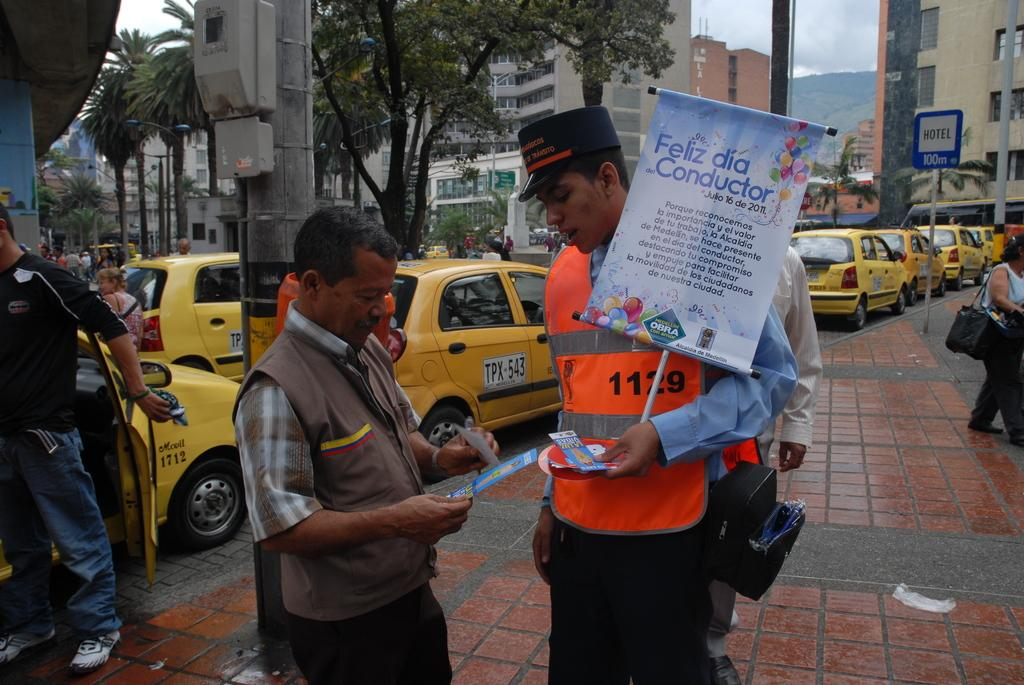<image>
Offer a succinct explanation of the picture presented. A man in a safety orange vest holding a sign that says Feliz dia Conductor. 